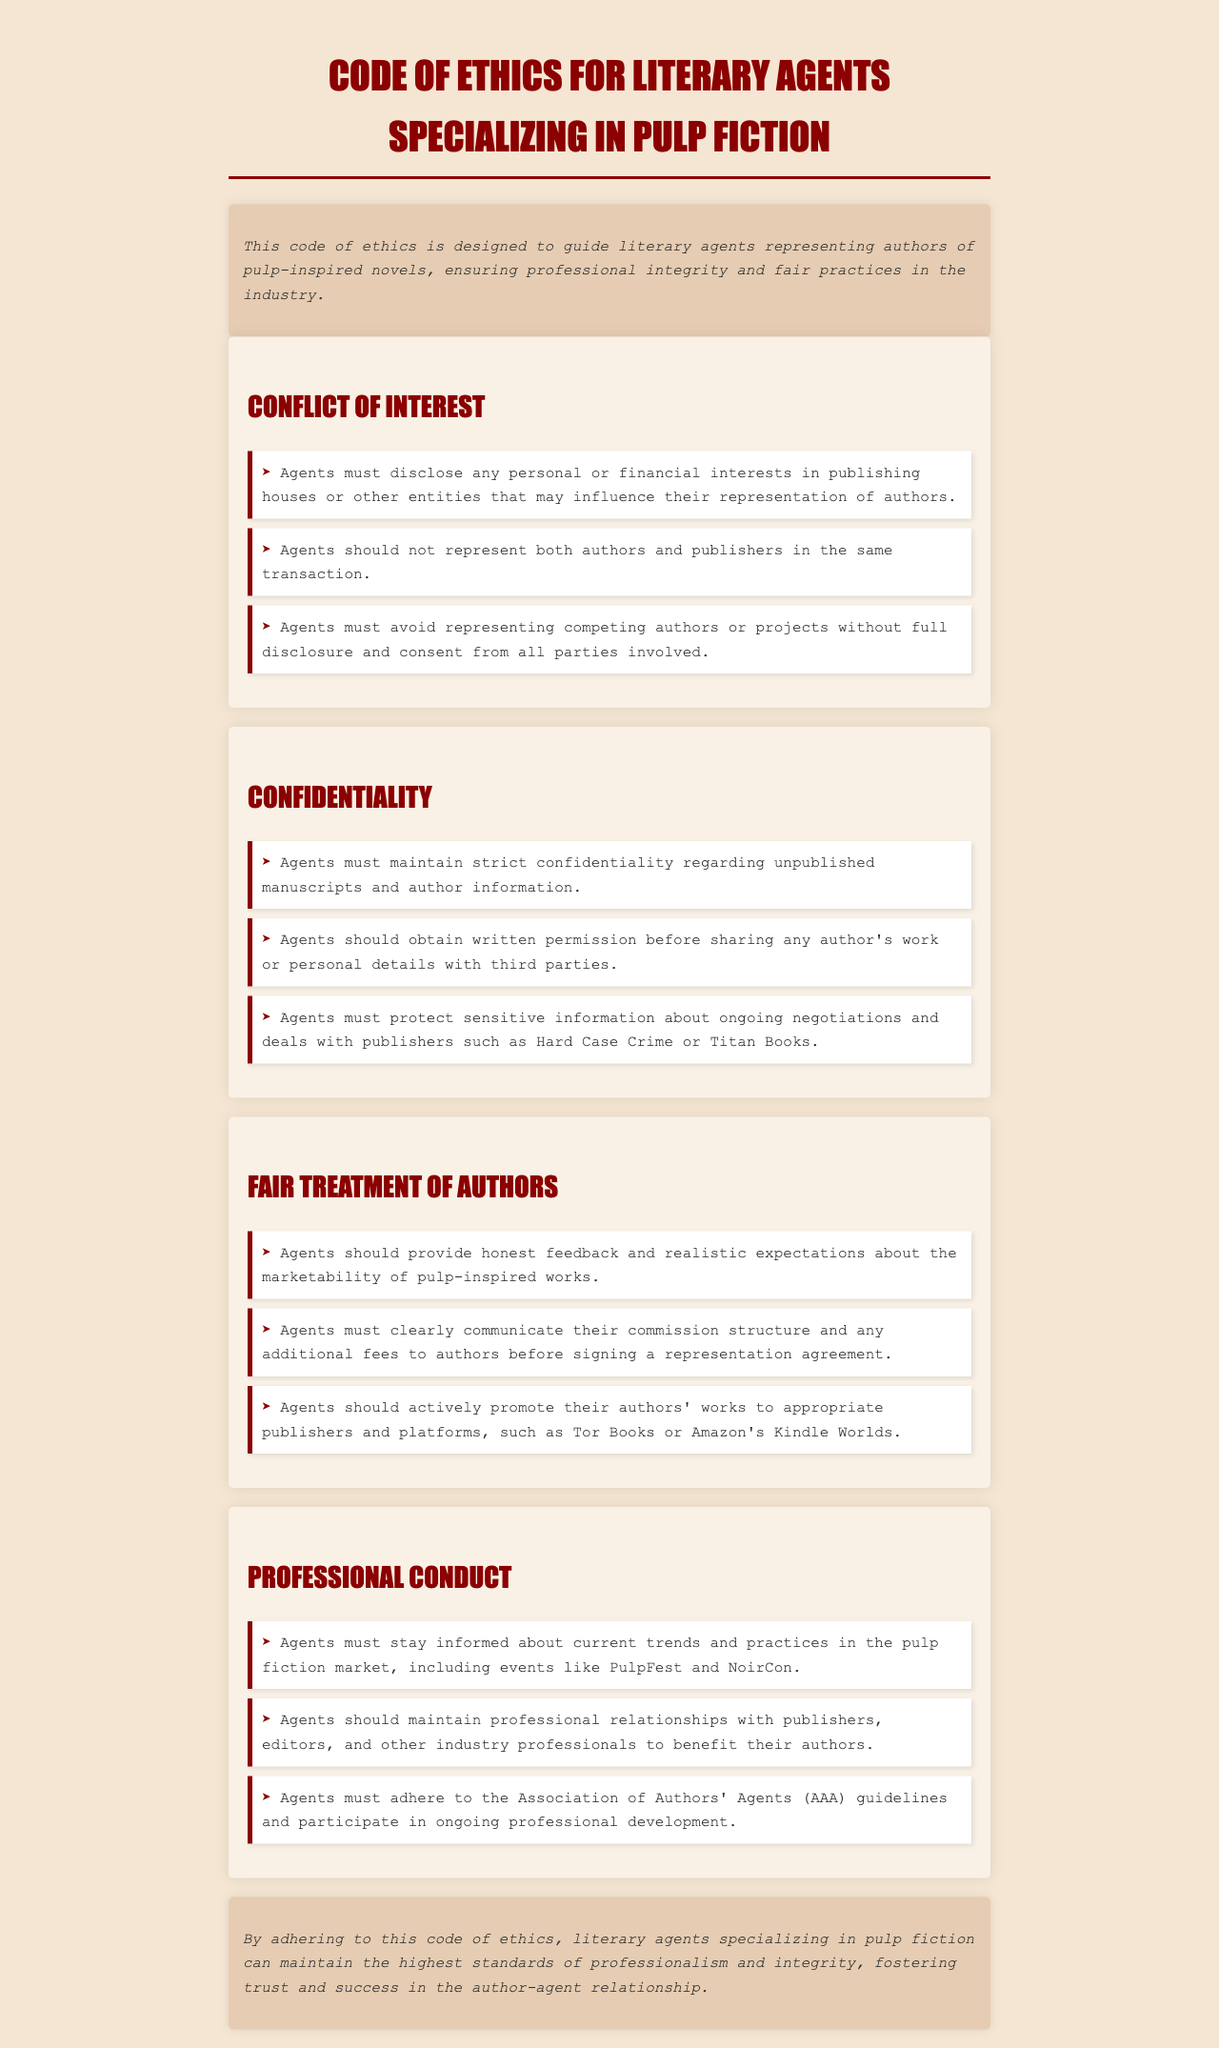What must agents disclose regarding their interests? Agents must disclose any personal or financial interests in publishing houses or other entities that may influence their representation of authors.
Answer: Personal or financial interests What should agents obtain before sharing an author’s work? Agents should obtain written permission before sharing any author's work or personal details with third parties.
Answer: Written permission What must agents clearly communicate to authors before signing? Agents must clearly communicate their commission structure and any additional fees to authors before signing a representation agreement.
Answer: Commission structure and additional fees What should agents avoid without consent from all parties? Agents must avoid representing competing authors or projects without full disclosure and consent from all parties involved.
Answer: Competing authors or projects How must agents maintain confidentiality? Agents must maintain strict confidentiality regarding unpublished manuscripts and author information.
Answer: Strict confidentiality How many guidelines must agents adhere to from AAA? Agents must adhere to the Association of Authors' Agents (AAA) guidelines.
Answer: Guidelines What should agents actively promote to publishers? Agents should actively promote their authors' works to appropriate publishers and platforms.
Answer: Authors' works Which organizations should agents stay informed about? Agents must stay informed about current trends and practices in the pulp fiction market, including events like PulpFest and NoirCon.
Answer: PulpFest and NoirCon What is the purpose of this code of ethics? By adhering to this code of ethics, literary agents can maintain the highest standards of professionalism and integrity.
Answer: Maintain professionalism and integrity 